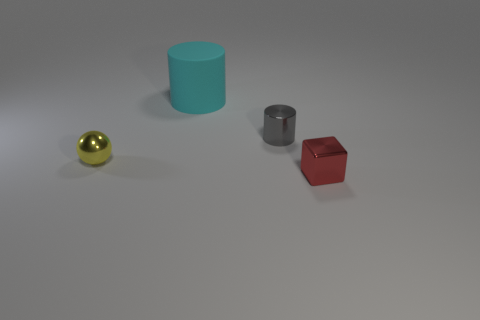Add 3 small red metallic objects. How many objects exist? 7 Subtract all balls. How many objects are left? 3 Subtract 0 purple balls. How many objects are left? 4 Subtract all large cyan things. Subtract all cyan matte cylinders. How many objects are left? 2 Add 1 small red metal blocks. How many small red metal blocks are left? 2 Add 2 tiny green rubber spheres. How many tiny green rubber spheres exist? 2 